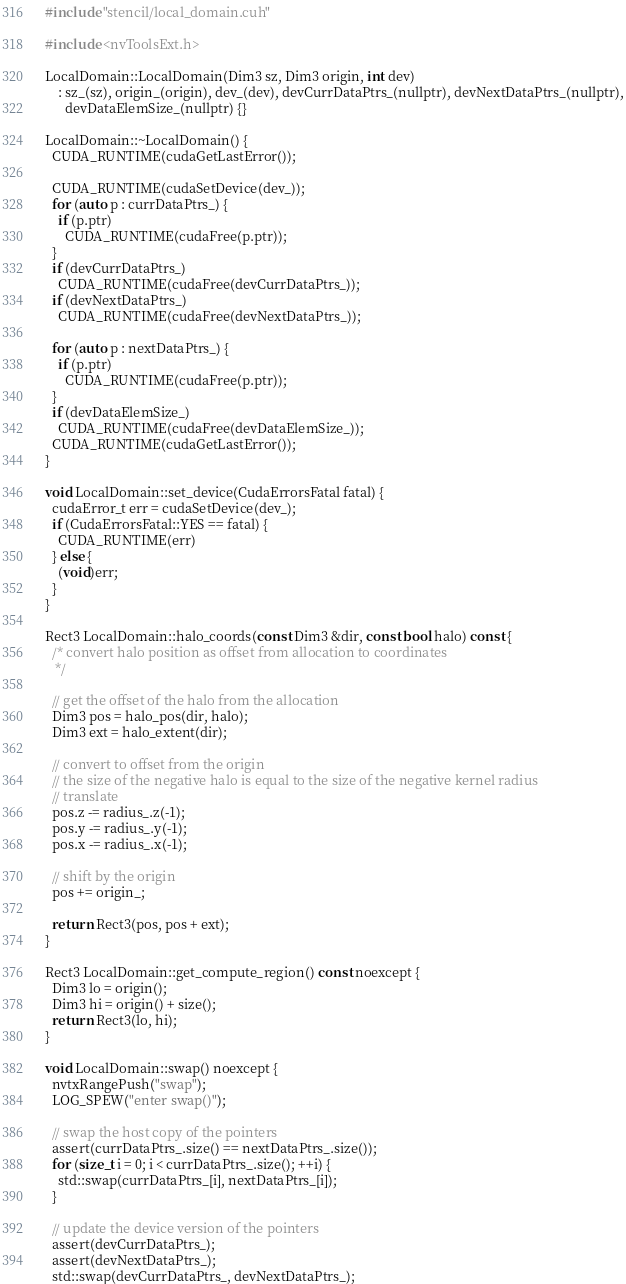Convert code to text. <code><loc_0><loc_0><loc_500><loc_500><_Cuda_>#include "stencil/local_domain.cuh"

#include <nvToolsExt.h>

LocalDomain::LocalDomain(Dim3 sz, Dim3 origin, int dev)
    : sz_(sz), origin_(origin), dev_(dev), devCurrDataPtrs_(nullptr), devNextDataPtrs_(nullptr),
      devDataElemSize_(nullptr) {}

LocalDomain::~LocalDomain() {
  CUDA_RUNTIME(cudaGetLastError());

  CUDA_RUNTIME(cudaSetDevice(dev_));
  for (auto p : currDataPtrs_) {
    if (p.ptr)
      CUDA_RUNTIME(cudaFree(p.ptr));
  }
  if (devCurrDataPtrs_)
    CUDA_RUNTIME(cudaFree(devCurrDataPtrs_));
  if (devNextDataPtrs_)
    CUDA_RUNTIME(cudaFree(devNextDataPtrs_));

  for (auto p : nextDataPtrs_) {
    if (p.ptr)
      CUDA_RUNTIME(cudaFree(p.ptr));
  }
  if (devDataElemSize_)
    CUDA_RUNTIME(cudaFree(devDataElemSize_));
  CUDA_RUNTIME(cudaGetLastError());
}

void LocalDomain::set_device(CudaErrorsFatal fatal) {
  cudaError_t err = cudaSetDevice(dev_);
  if (CudaErrorsFatal::YES == fatal) {
    CUDA_RUNTIME(err)
  } else {
    (void)err;
  }
}

Rect3 LocalDomain::halo_coords(const Dim3 &dir, const bool halo) const {
  /* convert halo position as offset from allocation to coordinates
   */

  // get the offset of the halo from the allocation
  Dim3 pos = halo_pos(dir, halo);
  Dim3 ext = halo_extent(dir);

  // convert to offset from the origin
  // the size of the negative halo is equal to the size of the negative kernel radius
  // translate
  pos.z -= radius_.z(-1);
  pos.y -= radius_.y(-1);
  pos.x -= radius_.x(-1);

  // shift by the origin
  pos += origin_;

  return Rect3(pos, pos + ext);
}

Rect3 LocalDomain::get_compute_region() const noexcept {
  Dim3 lo = origin();
  Dim3 hi = origin() + size();
  return Rect3(lo, hi);
}

void LocalDomain::swap() noexcept {
  nvtxRangePush("swap");
  LOG_SPEW("enter swap()");

  // swap the host copy of the pointers
  assert(currDataPtrs_.size() == nextDataPtrs_.size());
  for (size_t i = 0; i < currDataPtrs_.size(); ++i) {
    std::swap(currDataPtrs_[i], nextDataPtrs_[i]);
  }

  // update the device version of the pointers
  assert(devCurrDataPtrs_);
  assert(devNextDataPtrs_);
  std::swap(devCurrDataPtrs_, devNextDataPtrs_);
</code> 